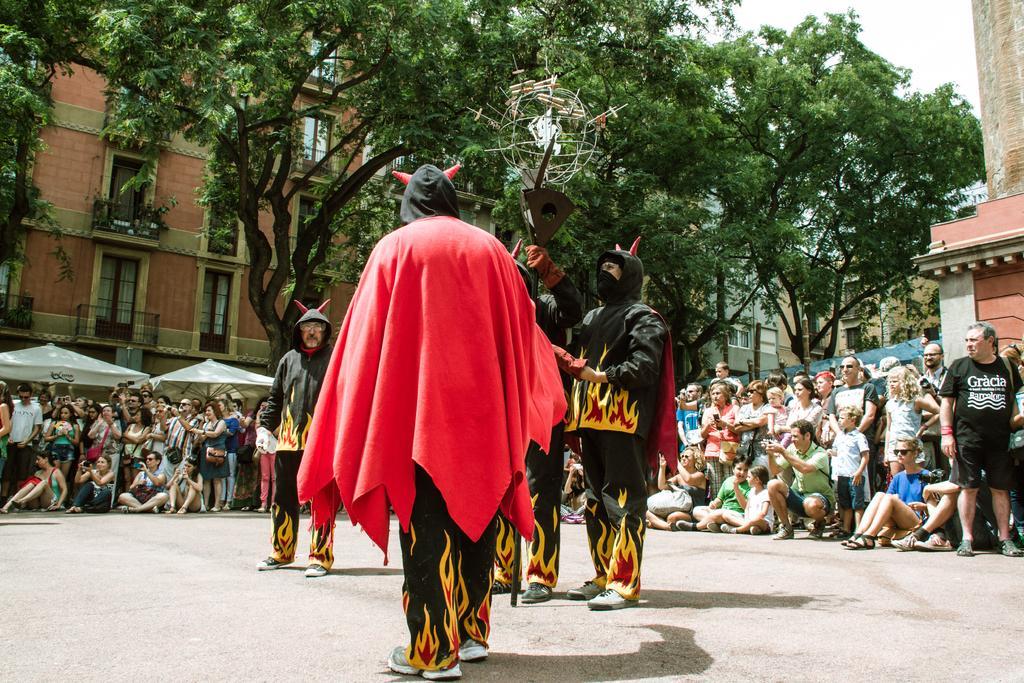Could you give a brief overview of what you see in this image? In this picture we can see some are doing magic show on the road, some people are standing and watching. Back side, we can see some buildings, trees. 